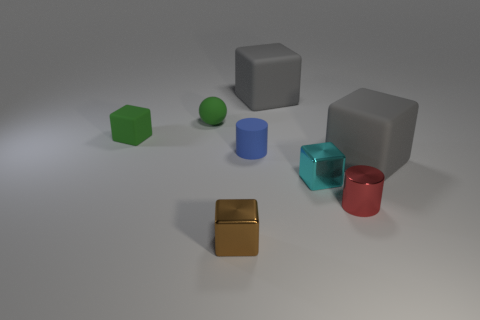What number of other things are the same shape as the small cyan metallic thing?
Offer a terse response. 4. What number of blocks are small brown things or small cyan metal objects?
Offer a terse response. 2. There is a matte cube left of the metallic cube in front of the small red shiny cylinder; is there a small cyan metallic thing behind it?
Provide a short and direct response. No. There is another tiny rubber object that is the same shape as the red thing; what color is it?
Provide a short and direct response. Blue. What number of blue things are small rubber things or small metallic cubes?
Offer a terse response. 1. What material is the big gray thing that is in front of the big cube left of the tiny red metal thing?
Give a very brief answer. Rubber. Does the brown shiny thing have the same shape as the small blue object?
Provide a succinct answer. No. The other cylinder that is the same size as the matte cylinder is what color?
Offer a very short reply. Red. Is there a small matte object that has the same color as the tiny sphere?
Your response must be concise. Yes. Is there a purple metallic cube?
Ensure brevity in your answer.  No. 